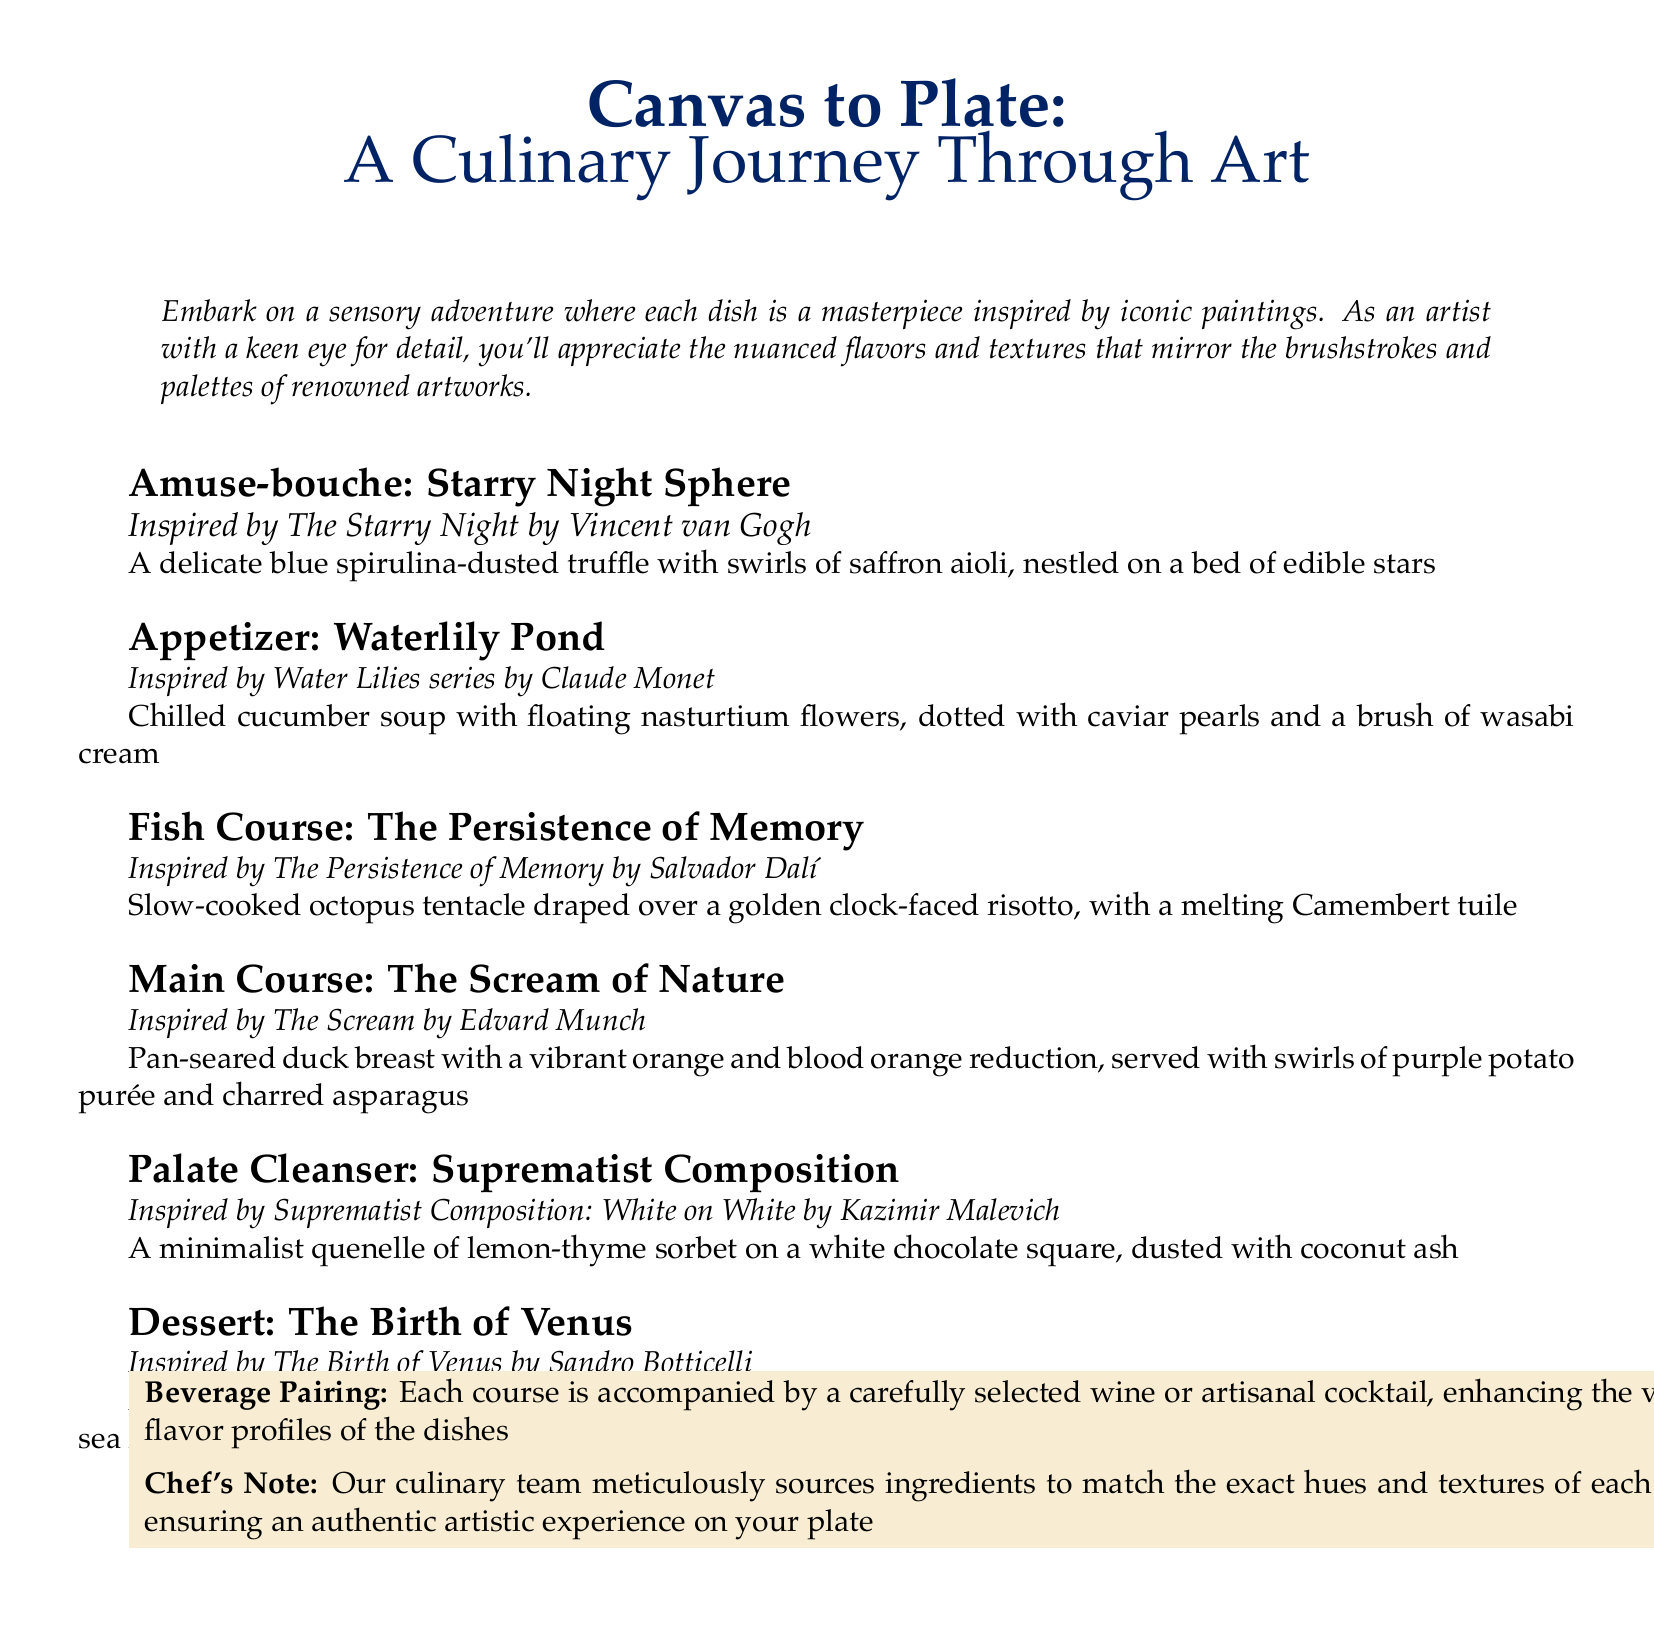What is the title of the tasting menu? The title is prominently displayed at the top of the document, introducing the theme of the culinary experience.
Answer: Canvas to Plate: A Culinary Journey Through Art Who is the artist behind the painting that inspired the Amuse-bouche? The painting that inspired the Amuse-bouche is attributed to Vincent van Gogh, as stated in the course details.
Answer: Vincent van Gogh What color accent is used in the document? The document specifies a particular color in RGB format, creating a thematic visual appeal.
Answer: goldaccent What is the main ingredient in the Fish Course? The Fish Course features a specific ingredient that is essential to its culinary identity, as noted in the description.
Answer: octopus How many courses are included in the tasting menu? By counting the course entries listed in the document, one can determine the total number of courses offered.
Answer: six What is the beverage pairing described as? The beverage pairing section highlights the intention behind the selections available for enhancing the meal experience.
Answer: carefully selected wine or artisanal cocktail Which course features a minimalist presentation? The course with a minimalist aesthetic is explicitly described, focusing on simplicity and form.
Answer: Palate Cleanser: Suprematist Composition What is the primary flavor profile of the dessert? The dessert's flavor profile is outlined in its description, emphasizing the predominant taste experience.
Answer: rosewater panna cotta What two colors are prominently featured in the Main Course? The description of the Main Course details specific colors that reflect its visual presentation, important for an experiential understanding.
Answer: vibrant orange and blood orange 